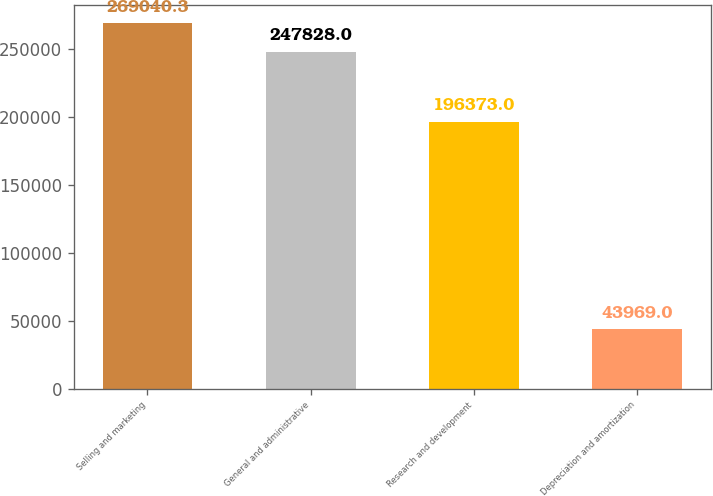Convert chart. <chart><loc_0><loc_0><loc_500><loc_500><bar_chart><fcel>Selling and marketing<fcel>General and administrative<fcel>Research and development<fcel>Depreciation and amortization<nl><fcel>269040<fcel>247828<fcel>196373<fcel>43969<nl></chart> 